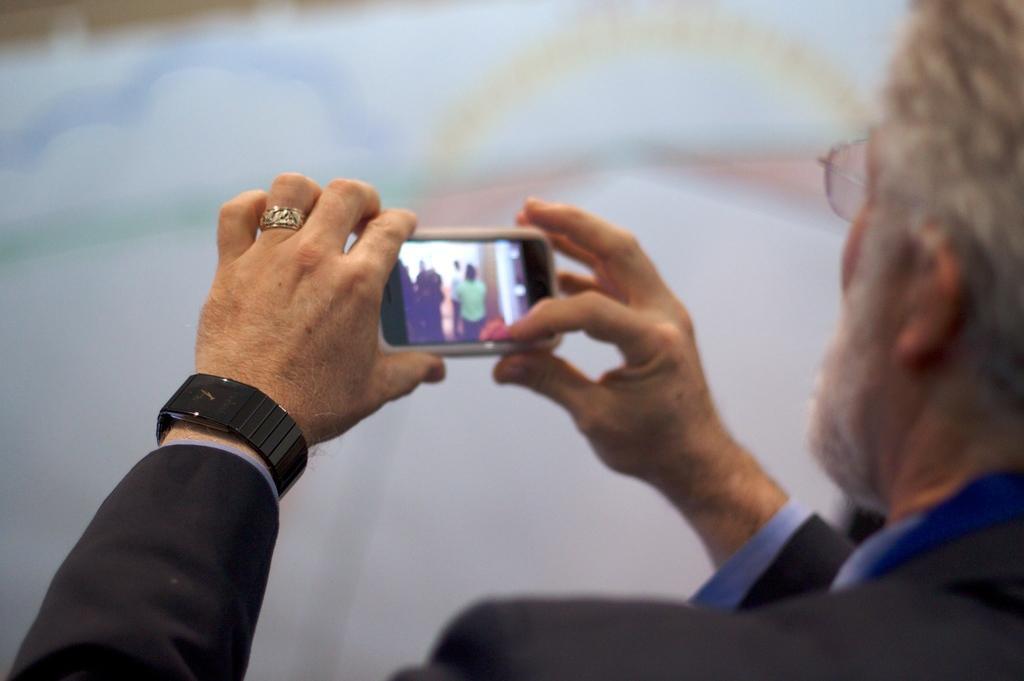How would you summarize this image in a sentence or two? This is a picture of a person who is holding the phone and taking the photo. 